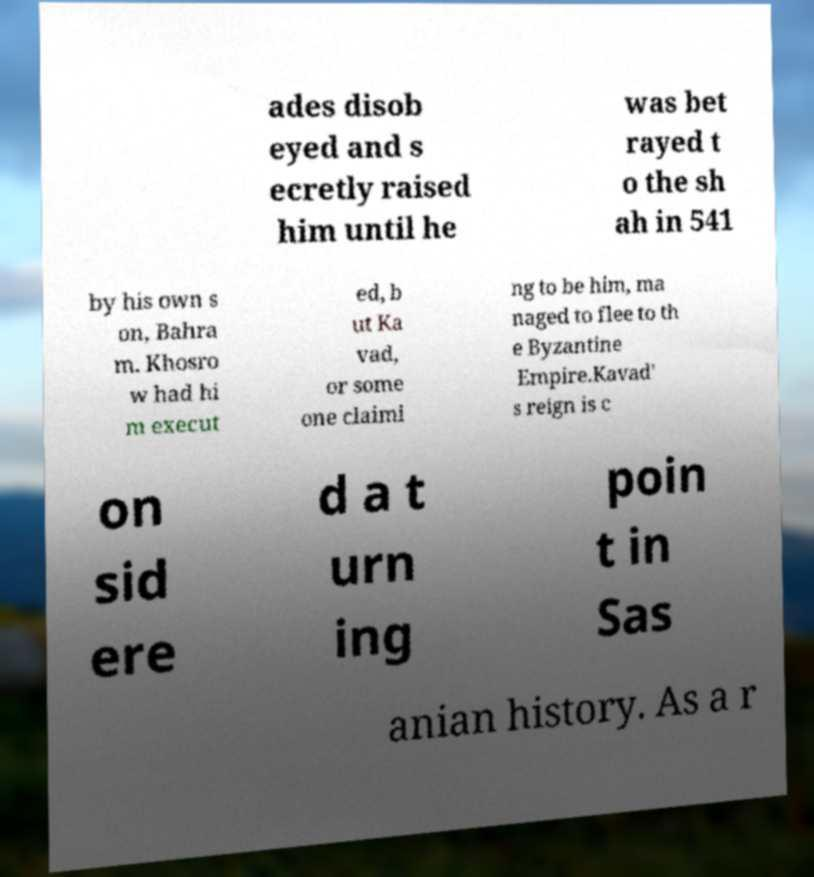Could you extract and type out the text from this image? ades disob eyed and s ecretly raised him until he was bet rayed t o the sh ah in 541 by his own s on, Bahra m. Khosro w had hi m execut ed, b ut Ka vad, or some one claimi ng to be him, ma naged to flee to th e Byzantine Empire.Kavad' s reign is c on sid ere d a t urn ing poin t in Sas anian history. As a r 